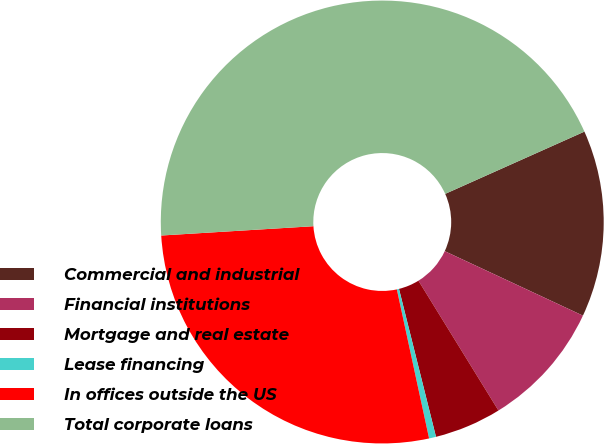Convert chart. <chart><loc_0><loc_0><loc_500><loc_500><pie_chart><fcel>Commercial and industrial<fcel>Financial institutions<fcel>Mortgage and real estate<fcel>Lease financing<fcel>In offices outside the US<fcel>Total corporate loans<nl><fcel>13.64%<fcel>9.26%<fcel>4.89%<fcel>0.51%<fcel>27.42%<fcel>44.28%<nl></chart> 